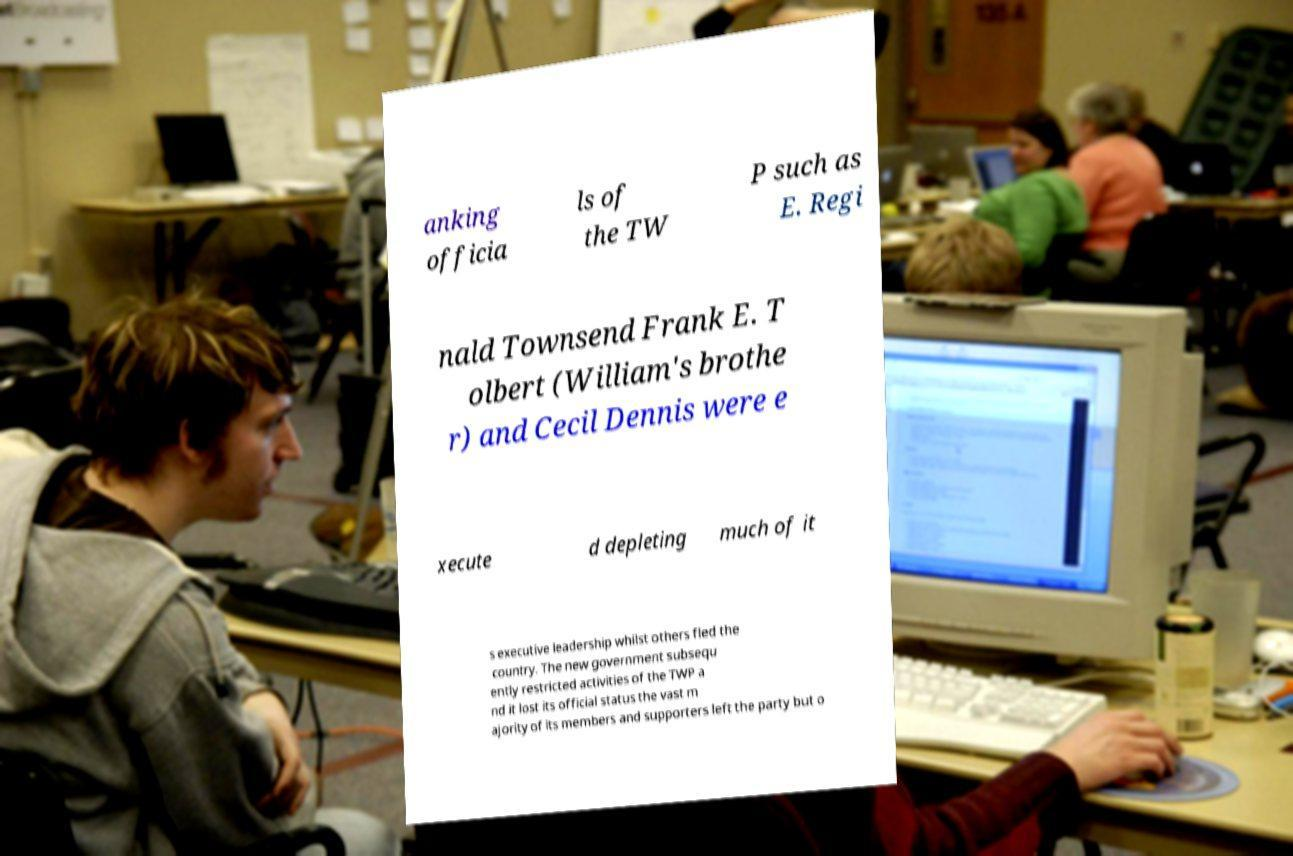Please read and relay the text visible in this image. What does it say? anking officia ls of the TW P such as E. Regi nald Townsend Frank E. T olbert (William's brothe r) and Cecil Dennis were e xecute d depleting much of it s executive leadership whilst others fled the country. The new government subsequ ently restricted activities of the TWP a nd it lost its official status the vast m ajority of its members and supporters left the party but o 